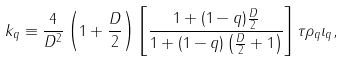<formula> <loc_0><loc_0><loc_500><loc_500>k _ { q } \equiv \frac { 4 } { D ^ { 2 } } \left ( 1 + \frac { D } { 2 } \right ) \left [ \frac { 1 + ( 1 - q ) \frac { D } { 2 } } { 1 + ( 1 - q ) \left ( \frac { D } { 2 } + 1 \right ) } \right ] \tau \rho _ { q } \iota _ { q } ,</formula> 